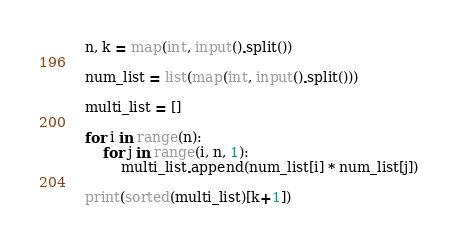Convert code to text. <code><loc_0><loc_0><loc_500><loc_500><_Python_>n, k = map(int, input().split())

num_list = list(map(int, input().split()))

multi_list = []

for i in range(n):
    for j in range(i, n, 1):
        multi_list.append(num_list[i] * num_list[j])

print(sorted(multi_list)[k+1])</code> 